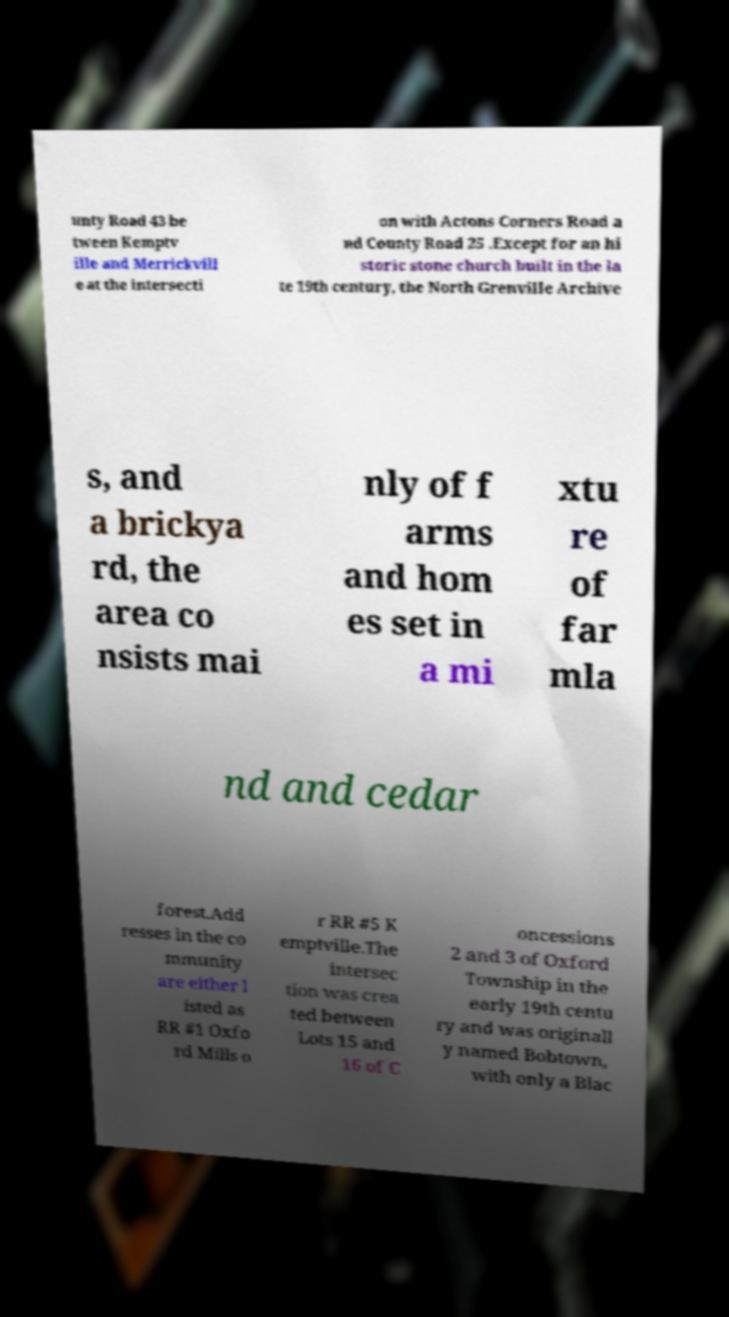Could you assist in decoding the text presented in this image and type it out clearly? unty Road 43 be tween Kemptv ille and Merrickvill e at the intersecti on with Actons Corners Road a nd County Road 25 .Except for an hi storic stone church built in the la te 19th century, the North Grenville Archive s, and a brickya rd, the area co nsists mai nly of f arms and hom es set in a mi xtu re of far mla nd and cedar forest.Add resses in the co mmunity are either l isted as RR #1 Oxfo rd Mills o r RR #5 K emptville.The intersec tion was crea ted between Lots 15 and 16 of C oncessions 2 and 3 of Oxford Township in the early 19th centu ry and was originall y named Bobtown, with only a Blac 